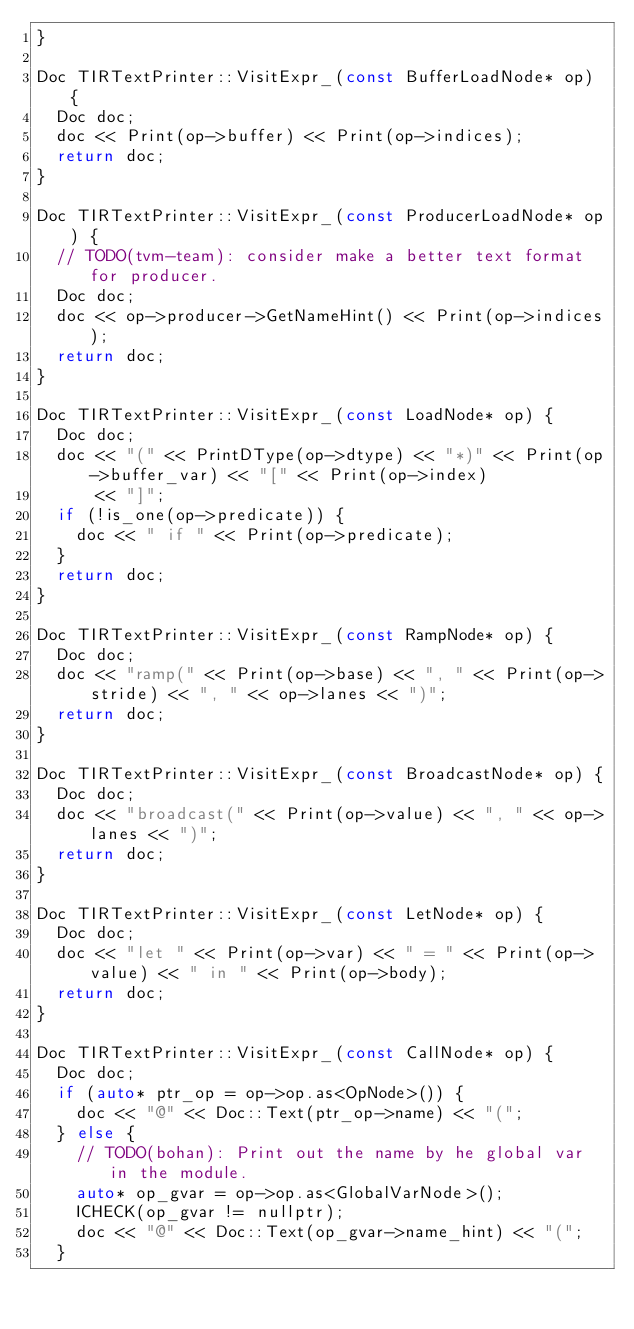Convert code to text. <code><loc_0><loc_0><loc_500><loc_500><_C++_>}

Doc TIRTextPrinter::VisitExpr_(const BufferLoadNode* op) {
  Doc doc;
  doc << Print(op->buffer) << Print(op->indices);
  return doc;
}

Doc TIRTextPrinter::VisitExpr_(const ProducerLoadNode* op) {
  // TODO(tvm-team): consider make a better text format for producer.
  Doc doc;
  doc << op->producer->GetNameHint() << Print(op->indices);
  return doc;
}

Doc TIRTextPrinter::VisitExpr_(const LoadNode* op) {
  Doc doc;
  doc << "(" << PrintDType(op->dtype) << "*)" << Print(op->buffer_var) << "[" << Print(op->index)
      << "]";
  if (!is_one(op->predicate)) {
    doc << " if " << Print(op->predicate);
  }
  return doc;
}

Doc TIRTextPrinter::VisitExpr_(const RampNode* op) {
  Doc doc;
  doc << "ramp(" << Print(op->base) << ", " << Print(op->stride) << ", " << op->lanes << ")";
  return doc;
}

Doc TIRTextPrinter::VisitExpr_(const BroadcastNode* op) {
  Doc doc;
  doc << "broadcast(" << Print(op->value) << ", " << op->lanes << ")";
  return doc;
}

Doc TIRTextPrinter::VisitExpr_(const LetNode* op) {
  Doc doc;
  doc << "let " << Print(op->var) << " = " << Print(op->value) << " in " << Print(op->body);
  return doc;
}

Doc TIRTextPrinter::VisitExpr_(const CallNode* op) {
  Doc doc;
  if (auto* ptr_op = op->op.as<OpNode>()) {
    doc << "@" << Doc::Text(ptr_op->name) << "(";
  } else {
    // TODO(bohan): Print out the name by he global var in the module.
    auto* op_gvar = op->op.as<GlobalVarNode>();
    ICHECK(op_gvar != nullptr);
    doc << "@" << Doc::Text(op_gvar->name_hint) << "(";
  }</code> 